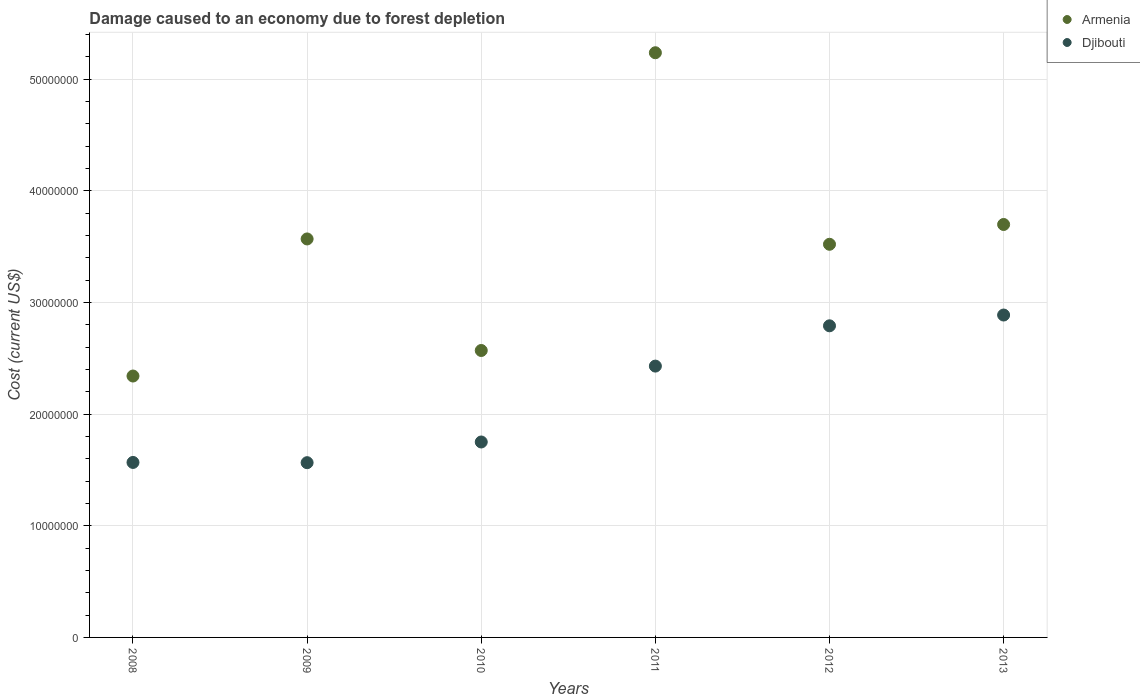How many different coloured dotlines are there?
Offer a very short reply. 2. Is the number of dotlines equal to the number of legend labels?
Make the answer very short. Yes. What is the cost of damage caused due to forest depletion in Djibouti in 2011?
Keep it short and to the point. 2.43e+07. Across all years, what is the maximum cost of damage caused due to forest depletion in Armenia?
Give a very brief answer. 5.24e+07. Across all years, what is the minimum cost of damage caused due to forest depletion in Djibouti?
Offer a very short reply. 1.57e+07. In which year was the cost of damage caused due to forest depletion in Armenia maximum?
Your response must be concise. 2011. In which year was the cost of damage caused due to forest depletion in Armenia minimum?
Offer a terse response. 2008. What is the total cost of damage caused due to forest depletion in Armenia in the graph?
Ensure brevity in your answer.  2.09e+08. What is the difference between the cost of damage caused due to forest depletion in Armenia in 2010 and that in 2013?
Offer a terse response. -1.13e+07. What is the difference between the cost of damage caused due to forest depletion in Armenia in 2013 and the cost of damage caused due to forest depletion in Djibouti in 2008?
Provide a succinct answer. 2.13e+07. What is the average cost of damage caused due to forest depletion in Armenia per year?
Your answer should be compact. 3.49e+07. In the year 2011, what is the difference between the cost of damage caused due to forest depletion in Armenia and cost of damage caused due to forest depletion in Djibouti?
Make the answer very short. 2.81e+07. In how many years, is the cost of damage caused due to forest depletion in Armenia greater than 32000000 US$?
Ensure brevity in your answer.  4. What is the ratio of the cost of damage caused due to forest depletion in Armenia in 2010 to that in 2011?
Ensure brevity in your answer.  0.49. What is the difference between the highest and the second highest cost of damage caused due to forest depletion in Djibouti?
Your answer should be very brief. 9.66e+05. What is the difference between the highest and the lowest cost of damage caused due to forest depletion in Armenia?
Your answer should be very brief. 2.90e+07. In how many years, is the cost of damage caused due to forest depletion in Armenia greater than the average cost of damage caused due to forest depletion in Armenia taken over all years?
Offer a terse response. 4. Is the cost of damage caused due to forest depletion in Armenia strictly greater than the cost of damage caused due to forest depletion in Djibouti over the years?
Give a very brief answer. Yes. Is the cost of damage caused due to forest depletion in Djibouti strictly less than the cost of damage caused due to forest depletion in Armenia over the years?
Your response must be concise. Yes. How many years are there in the graph?
Keep it short and to the point. 6. Does the graph contain any zero values?
Give a very brief answer. No. Where does the legend appear in the graph?
Ensure brevity in your answer.  Top right. How many legend labels are there?
Your answer should be very brief. 2. What is the title of the graph?
Offer a terse response. Damage caused to an economy due to forest depletion. What is the label or title of the X-axis?
Keep it short and to the point. Years. What is the label or title of the Y-axis?
Provide a succinct answer. Cost (current US$). What is the Cost (current US$) in Armenia in 2008?
Make the answer very short. 2.34e+07. What is the Cost (current US$) in Djibouti in 2008?
Provide a short and direct response. 1.57e+07. What is the Cost (current US$) in Armenia in 2009?
Your response must be concise. 3.57e+07. What is the Cost (current US$) in Djibouti in 2009?
Your answer should be compact. 1.57e+07. What is the Cost (current US$) of Armenia in 2010?
Offer a very short reply. 2.57e+07. What is the Cost (current US$) of Djibouti in 2010?
Your answer should be compact. 1.75e+07. What is the Cost (current US$) of Armenia in 2011?
Offer a terse response. 5.24e+07. What is the Cost (current US$) in Djibouti in 2011?
Your answer should be compact. 2.43e+07. What is the Cost (current US$) in Armenia in 2012?
Provide a succinct answer. 3.52e+07. What is the Cost (current US$) in Djibouti in 2012?
Your response must be concise. 2.79e+07. What is the Cost (current US$) of Armenia in 2013?
Give a very brief answer. 3.70e+07. What is the Cost (current US$) of Djibouti in 2013?
Ensure brevity in your answer.  2.89e+07. Across all years, what is the maximum Cost (current US$) in Armenia?
Make the answer very short. 5.24e+07. Across all years, what is the maximum Cost (current US$) in Djibouti?
Give a very brief answer. 2.89e+07. Across all years, what is the minimum Cost (current US$) of Armenia?
Your answer should be compact. 2.34e+07. Across all years, what is the minimum Cost (current US$) of Djibouti?
Your answer should be compact. 1.57e+07. What is the total Cost (current US$) in Armenia in the graph?
Provide a succinct answer. 2.09e+08. What is the total Cost (current US$) of Djibouti in the graph?
Offer a terse response. 1.30e+08. What is the difference between the Cost (current US$) in Armenia in 2008 and that in 2009?
Offer a very short reply. -1.23e+07. What is the difference between the Cost (current US$) of Djibouti in 2008 and that in 2009?
Your answer should be compact. 2.17e+04. What is the difference between the Cost (current US$) of Armenia in 2008 and that in 2010?
Your answer should be compact. -2.29e+06. What is the difference between the Cost (current US$) in Djibouti in 2008 and that in 2010?
Ensure brevity in your answer.  -1.83e+06. What is the difference between the Cost (current US$) in Armenia in 2008 and that in 2011?
Give a very brief answer. -2.90e+07. What is the difference between the Cost (current US$) in Djibouti in 2008 and that in 2011?
Ensure brevity in your answer.  -8.63e+06. What is the difference between the Cost (current US$) of Armenia in 2008 and that in 2012?
Provide a short and direct response. -1.18e+07. What is the difference between the Cost (current US$) of Djibouti in 2008 and that in 2012?
Give a very brief answer. -1.22e+07. What is the difference between the Cost (current US$) of Armenia in 2008 and that in 2013?
Give a very brief answer. -1.36e+07. What is the difference between the Cost (current US$) of Djibouti in 2008 and that in 2013?
Ensure brevity in your answer.  -1.32e+07. What is the difference between the Cost (current US$) of Armenia in 2009 and that in 2010?
Make the answer very short. 9.99e+06. What is the difference between the Cost (current US$) of Djibouti in 2009 and that in 2010?
Your answer should be very brief. -1.85e+06. What is the difference between the Cost (current US$) of Armenia in 2009 and that in 2011?
Provide a succinct answer. -1.67e+07. What is the difference between the Cost (current US$) in Djibouti in 2009 and that in 2011?
Ensure brevity in your answer.  -8.65e+06. What is the difference between the Cost (current US$) in Armenia in 2009 and that in 2012?
Your answer should be very brief. 4.78e+05. What is the difference between the Cost (current US$) in Djibouti in 2009 and that in 2012?
Offer a very short reply. -1.23e+07. What is the difference between the Cost (current US$) in Armenia in 2009 and that in 2013?
Ensure brevity in your answer.  -1.30e+06. What is the difference between the Cost (current US$) of Djibouti in 2009 and that in 2013?
Give a very brief answer. -1.32e+07. What is the difference between the Cost (current US$) of Armenia in 2010 and that in 2011?
Offer a very short reply. -2.67e+07. What is the difference between the Cost (current US$) in Djibouti in 2010 and that in 2011?
Provide a short and direct response. -6.80e+06. What is the difference between the Cost (current US$) in Armenia in 2010 and that in 2012?
Offer a terse response. -9.51e+06. What is the difference between the Cost (current US$) in Djibouti in 2010 and that in 2012?
Provide a succinct answer. -1.04e+07. What is the difference between the Cost (current US$) in Armenia in 2010 and that in 2013?
Your response must be concise. -1.13e+07. What is the difference between the Cost (current US$) in Djibouti in 2010 and that in 2013?
Ensure brevity in your answer.  -1.14e+07. What is the difference between the Cost (current US$) in Armenia in 2011 and that in 2012?
Your answer should be very brief. 1.72e+07. What is the difference between the Cost (current US$) in Djibouti in 2011 and that in 2012?
Give a very brief answer. -3.61e+06. What is the difference between the Cost (current US$) in Armenia in 2011 and that in 2013?
Give a very brief answer. 1.54e+07. What is the difference between the Cost (current US$) of Djibouti in 2011 and that in 2013?
Your answer should be very brief. -4.57e+06. What is the difference between the Cost (current US$) of Armenia in 2012 and that in 2013?
Your answer should be very brief. -1.77e+06. What is the difference between the Cost (current US$) in Djibouti in 2012 and that in 2013?
Provide a short and direct response. -9.66e+05. What is the difference between the Cost (current US$) of Armenia in 2008 and the Cost (current US$) of Djibouti in 2009?
Make the answer very short. 7.76e+06. What is the difference between the Cost (current US$) of Armenia in 2008 and the Cost (current US$) of Djibouti in 2010?
Offer a very short reply. 5.91e+06. What is the difference between the Cost (current US$) in Armenia in 2008 and the Cost (current US$) in Djibouti in 2011?
Your response must be concise. -8.89e+05. What is the difference between the Cost (current US$) of Armenia in 2008 and the Cost (current US$) of Djibouti in 2012?
Keep it short and to the point. -4.50e+06. What is the difference between the Cost (current US$) in Armenia in 2008 and the Cost (current US$) in Djibouti in 2013?
Make the answer very short. -5.46e+06. What is the difference between the Cost (current US$) in Armenia in 2009 and the Cost (current US$) in Djibouti in 2010?
Your answer should be compact. 1.82e+07. What is the difference between the Cost (current US$) in Armenia in 2009 and the Cost (current US$) in Djibouti in 2011?
Give a very brief answer. 1.14e+07. What is the difference between the Cost (current US$) of Armenia in 2009 and the Cost (current US$) of Djibouti in 2012?
Keep it short and to the point. 7.78e+06. What is the difference between the Cost (current US$) in Armenia in 2009 and the Cost (current US$) in Djibouti in 2013?
Make the answer very short. 6.82e+06. What is the difference between the Cost (current US$) in Armenia in 2010 and the Cost (current US$) in Djibouti in 2011?
Offer a terse response. 1.40e+06. What is the difference between the Cost (current US$) of Armenia in 2010 and the Cost (current US$) of Djibouti in 2012?
Give a very brief answer. -2.21e+06. What is the difference between the Cost (current US$) in Armenia in 2010 and the Cost (current US$) in Djibouti in 2013?
Your answer should be compact. -3.18e+06. What is the difference between the Cost (current US$) of Armenia in 2011 and the Cost (current US$) of Djibouti in 2012?
Give a very brief answer. 2.45e+07. What is the difference between the Cost (current US$) of Armenia in 2011 and the Cost (current US$) of Djibouti in 2013?
Make the answer very short. 2.35e+07. What is the difference between the Cost (current US$) of Armenia in 2012 and the Cost (current US$) of Djibouti in 2013?
Your answer should be compact. 6.34e+06. What is the average Cost (current US$) in Armenia per year?
Make the answer very short. 3.49e+07. What is the average Cost (current US$) in Djibouti per year?
Make the answer very short. 2.17e+07. In the year 2008, what is the difference between the Cost (current US$) in Armenia and Cost (current US$) in Djibouti?
Keep it short and to the point. 7.74e+06. In the year 2009, what is the difference between the Cost (current US$) in Armenia and Cost (current US$) in Djibouti?
Provide a succinct answer. 2.00e+07. In the year 2010, what is the difference between the Cost (current US$) of Armenia and Cost (current US$) of Djibouti?
Your answer should be very brief. 8.20e+06. In the year 2011, what is the difference between the Cost (current US$) of Armenia and Cost (current US$) of Djibouti?
Your response must be concise. 2.81e+07. In the year 2012, what is the difference between the Cost (current US$) in Armenia and Cost (current US$) in Djibouti?
Your answer should be very brief. 7.30e+06. In the year 2013, what is the difference between the Cost (current US$) of Armenia and Cost (current US$) of Djibouti?
Your answer should be very brief. 8.11e+06. What is the ratio of the Cost (current US$) in Armenia in 2008 to that in 2009?
Give a very brief answer. 0.66. What is the ratio of the Cost (current US$) in Armenia in 2008 to that in 2010?
Your response must be concise. 0.91. What is the ratio of the Cost (current US$) in Djibouti in 2008 to that in 2010?
Ensure brevity in your answer.  0.9. What is the ratio of the Cost (current US$) in Armenia in 2008 to that in 2011?
Your answer should be very brief. 0.45. What is the ratio of the Cost (current US$) of Djibouti in 2008 to that in 2011?
Offer a very short reply. 0.64. What is the ratio of the Cost (current US$) of Armenia in 2008 to that in 2012?
Ensure brevity in your answer.  0.66. What is the ratio of the Cost (current US$) of Djibouti in 2008 to that in 2012?
Offer a very short reply. 0.56. What is the ratio of the Cost (current US$) of Armenia in 2008 to that in 2013?
Your answer should be very brief. 0.63. What is the ratio of the Cost (current US$) in Djibouti in 2008 to that in 2013?
Your answer should be compact. 0.54. What is the ratio of the Cost (current US$) of Armenia in 2009 to that in 2010?
Your answer should be compact. 1.39. What is the ratio of the Cost (current US$) of Djibouti in 2009 to that in 2010?
Offer a terse response. 0.89. What is the ratio of the Cost (current US$) in Armenia in 2009 to that in 2011?
Your answer should be very brief. 0.68. What is the ratio of the Cost (current US$) of Djibouti in 2009 to that in 2011?
Keep it short and to the point. 0.64. What is the ratio of the Cost (current US$) in Armenia in 2009 to that in 2012?
Provide a short and direct response. 1.01. What is the ratio of the Cost (current US$) of Djibouti in 2009 to that in 2012?
Your answer should be compact. 0.56. What is the ratio of the Cost (current US$) in Armenia in 2009 to that in 2013?
Your answer should be very brief. 0.96. What is the ratio of the Cost (current US$) of Djibouti in 2009 to that in 2013?
Keep it short and to the point. 0.54. What is the ratio of the Cost (current US$) of Armenia in 2010 to that in 2011?
Keep it short and to the point. 0.49. What is the ratio of the Cost (current US$) in Djibouti in 2010 to that in 2011?
Your response must be concise. 0.72. What is the ratio of the Cost (current US$) of Armenia in 2010 to that in 2012?
Provide a succinct answer. 0.73. What is the ratio of the Cost (current US$) of Djibouti in 2010 to that in 2012?
Offer a terse response. 0.63. What is the ratio of the Cost (current US$) in Armenia in 2010 to that in 2013?
Provide a short and direct response. 0.69. What is the ratio of the Cost (current US$) in Djibouti in 2010 to that in 2013?
Make the answer very short. 0.61. What is the ratio of the Cost (current US$) in Armenia in 2011 to that in 2012?
Provide a succinct answer. 1.49. What is the ratio of the Cost (current US$) in Djibouti in 2011 to that in 2012?
Give a very brief answer. 0.87. What is the ratio of the Cost (current US$) of Armenia in 2011 to that in 2013?
Ensure brevity in your answer.  1.42. What is the ratio of the Cost (current US$) of Djibouti in 2011 to that in 2013?
Offer a terse response. 0.84. What is the ratio of the Cost (current US$) of Armenia in 2012 to that in 2013?
Your response must be concise. 0.95. What is the ratio of the Cost (current US$) of Djibouti in 2012 to that in 2013?
Make the answer very short. 0.97. What is the difference between the highest and the second highest Cost (current US$) in Armenia?
Provide a succinct answer. 1.54e+07. What is the difference between the highest and the second highest Cost (current US$) in Djibouti?
Your answer should be compact. 9.66e+05. What is the difference between the highest and the lowest Cost (current US$) in Armenia?
Ensure brevity in your answer.  2.90e+07. What is the difference between the highest and the lowest Cost (current US$) of Djibouti?
Your answer should be compact. 1.32e+07. 